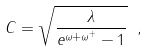Convert formula to latex. <formula><loc_0><loc_0><loc_500><loc_500>C = \sqrt { \frac { \lambda } { e ^ { \omega + \omega ^ { + } } - 1 } } \ ,</formula> 